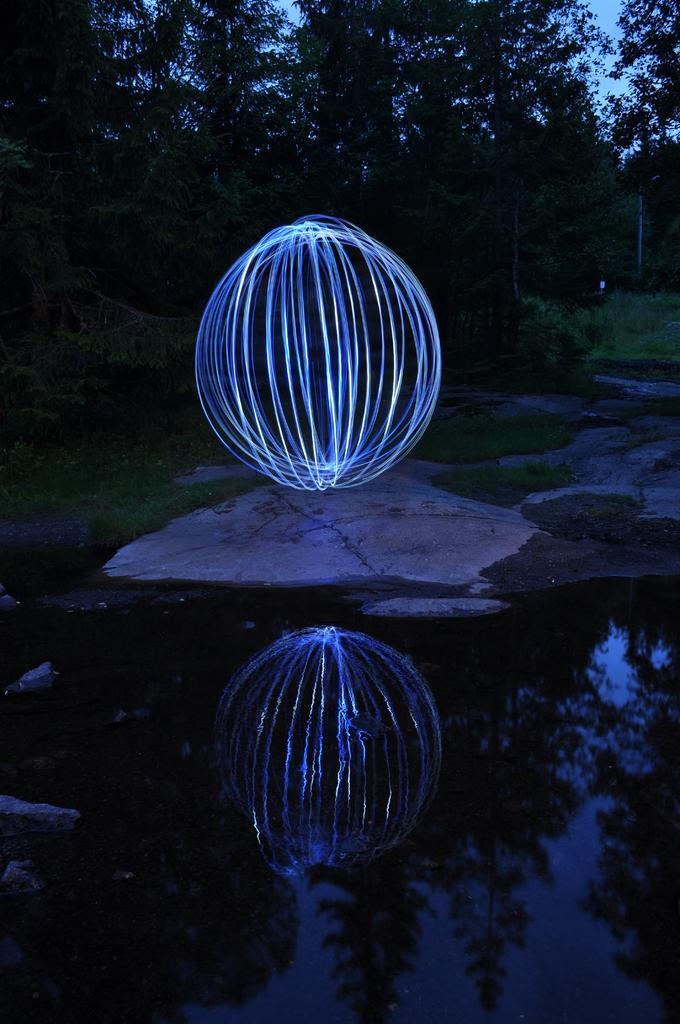Can you describe this image briefly? In this image we can see the circular object on the floor. We can also see the trees and also the water. Some part of the sky is also visible in this image. 